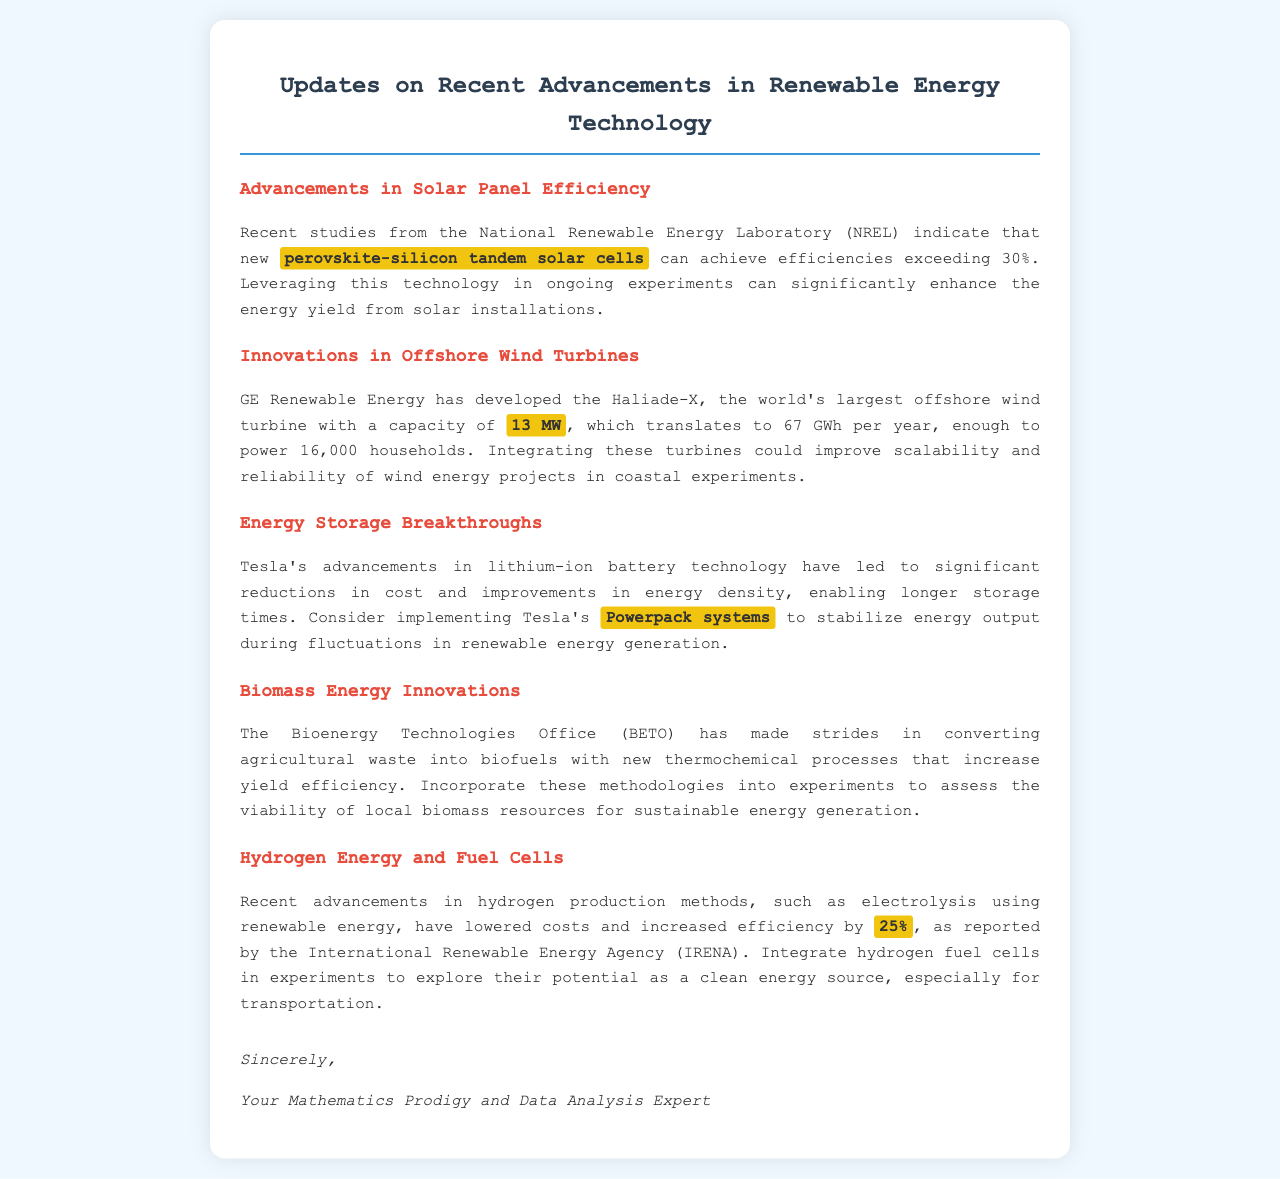What is the efficiency of perovskite-silicon tandem solar cells? The efficiency mentioned in the document is based on recent studies indicating that these solar cells can achieve efficiencies exceeding 30%.
Answer: exceeding 30% What is the capacity of the Haliade-X offshore wind turbine? The document states that the Haliade-X has a capacity of 13 MW.
Answer: 13 MW How much energy does the Haliade-X produce per year? The document notes that it translates to 67 GWh per year, which can power 16,000 households.
Answer: 67 GWh What improvements have Tesla made in their battery technology? The document describes significant reductions in cost and improvements in energy density for Tesla's lithium-ion battery technology.
Answer: reductions in cost and improvements in energy density What method has BETO developed for converting agricultural waste? The document highlights the development of new thermochemical processes by BETO for converting agricultural waste into biofuels.
Answer: thermochemical processes By how much have hydrogen production methods lowered costs? The document states that recent advancements have lowered costs and increased efficiency by 25%.
Answer: 25% What type of document is this? The document is an update letter about recent advancements in renewable energy technology relevant to ongoing experiments.
Answer: update letter Who is the author of the document? The document concludes with a signature from "Your Mathematics Prodigy and Data Analysis Expert."
Answer: Your Mathematics Prodigy and Data Analysis Expert 